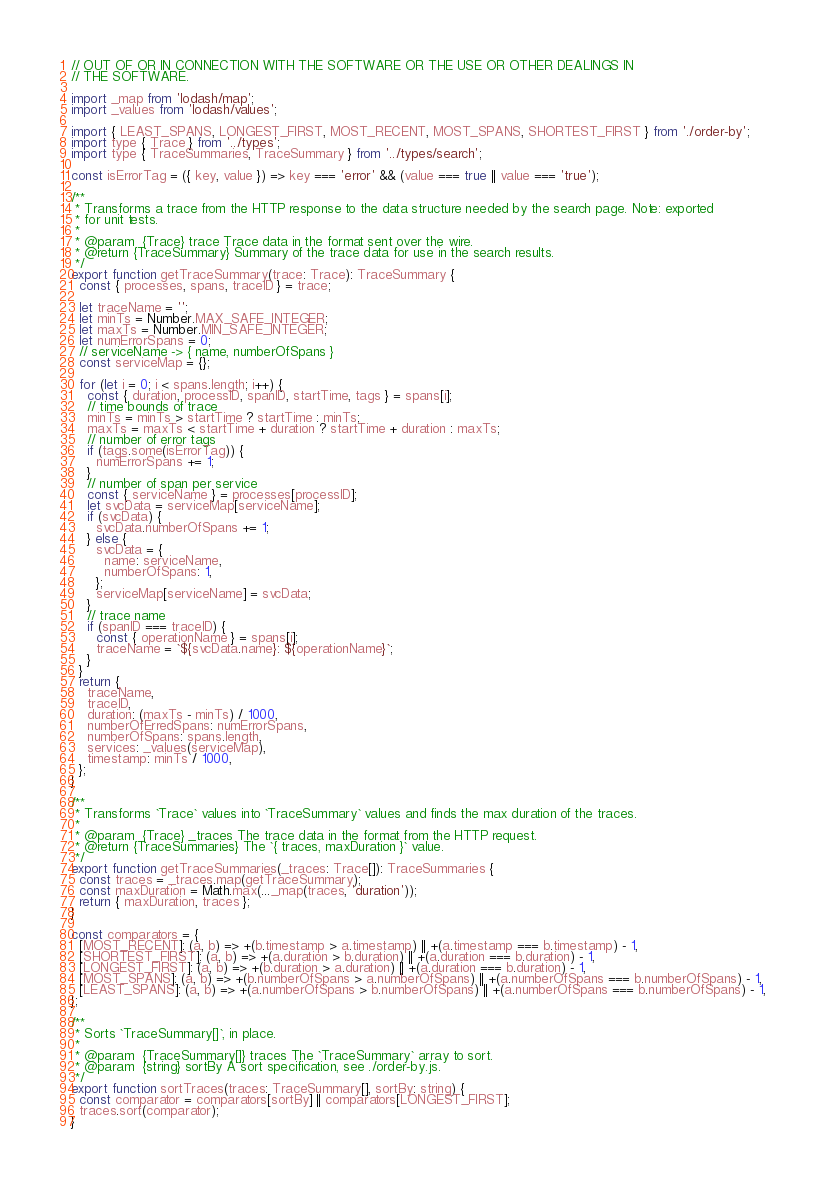Convert code to text. <code><loc_0><loc_0><loc_500><loc_500><_JavaScript_>// OUT OF OR IN CONNECTION WITH THE SOFTWARE OR THE USE OR OTHER DEALINGS IN
// THE SOFTWARE.

import _map from 'lodash/map';
import _values from 'lodash/values';

import { LEAST_SPANS, LONGEST_FIRST, MOST_RECENT, MOST_SPANS, SHORTEST_FIRST } from './order-by';
import type { Trace } from '../types';
import type { TraceSummaries, TraceSummary } from '../types/search';

const isErrorTag = ({ key, value }) => key === 'error' && (value === true || value === 'true');

/**
 * Transforms a trace from the HTTP response to the data structure needed by the search page. Note: exported
 * for unit tests.
 *
 * @param  {Trace} trace Trace data in the format sent over the wire.
 * @return {TraceSummary} Summary of the trace data for use in the search results.
 */
export function getTraceSummary(trace: Trace): TraceSummary {
  const { processes, spans, traceID } = trace;

  let traceName = '';
  let minTs = Number.MAX_SAFE_INTEGER;
  let maxTs = Number.MIN_SAFE_INTEGER;
  let numErrorSpans = 0;
  // serviceName -> { name, numberOfSpans }
  const serviceMap = {};

  for (let i = 0; i < spans.length; i++) {
    const { duration, processID, spanID, startTime, tags } = spans[i];
    // time bounds of trace
    minTs = minTs > startTime ? startTime : minTs;
    maxTs = maxTs < startTime + duration ? startTime + duration : maxTs;
    // number of error tags
    if (tags.some(isErrorTag)) {
      numErrorSpans += 1;
    }
    // number of span per service
    const { serviceName } = processes[processID];
    let svcData = serviceMap[serviceName];
    if (svcData) {
      svcData.numberOfSpans += 1;
    } else {
      svcData = {
        name: serviceName,
        numberOfSpans: 1,
      };
      serviceMap[serviceName] = svcData;
    }
    // trace name
    if (spanID === traceID) {
      const { operationName } = spans[i];
      traceName = `${svcData.name}: ${operationName}`;
    }
  }
  return {
    traceName,
    traceID,
    duration: (maxTs - minTs) / 1000,
    numberOfErredSpans: numErrorSpans,
    numberOfSpans: spans.length,
    services: _values(serviceMap),
    timestamp: minTs / 1000,
  };
}

/**
 * Transforms `Trace` values into `TraceSummary` values and finds the max duration of the traces.
 *
 * @param  {Trace} _traces The trace data in the format from the HTTP request.
 * @return {TraceSummaries} The `{ traces, maxDuration }` value.
 */
export function getTraceSummaries(_traces: Trace[]): TraceSummaries {
  const traces = _traces.map(getTraceSummary);
  const maxDuration = Math.max(..._map(traces, 'duration'));
  return { maxDuration, traces };
}

const comparators = {
  [MOST_RECENT]: (a, b) => +(b.timestamp > a.timestamp) || +(a.timestamp === b.timestamp) - 1,
  [SHORTEST_FIRST]: (a, b) => +(a.duration > b.duration) || +(a.duration === b.duration) - 1,
  [LONGEST_FIRST]: (a, b) => +(b.duration > a.duration) || +(a.duration === b.duration) - 1,
  [MOST_SPANS]: (a, b) => +(b.numberOfSpans > a.numberOfSpans) || +(a.numberOfSpans === b.numberOfSpans) - 1,
  [LEAST_SPANS]: (a, b) => +(a.numberOfSpans > b.numberOfSpans) || +(a.numberOfSpans === b.numberOfSpans) - 1,
};

/**
 * Sorts `TraceSummary[]`, in place.
 *
 * @param  {TraceSummary[]} traces The `TraceSummary` array to sort.
 * @param  {string} sortBy A sort specification, see ./order-by.js.
 */
export function sortTraces(traces: TraceSummary[], sortBy: string) {
  const comparator = comparators[sortBy] || comparators[LONGEST_FIRST];
  traces.sort(comparator);
}
</code> 